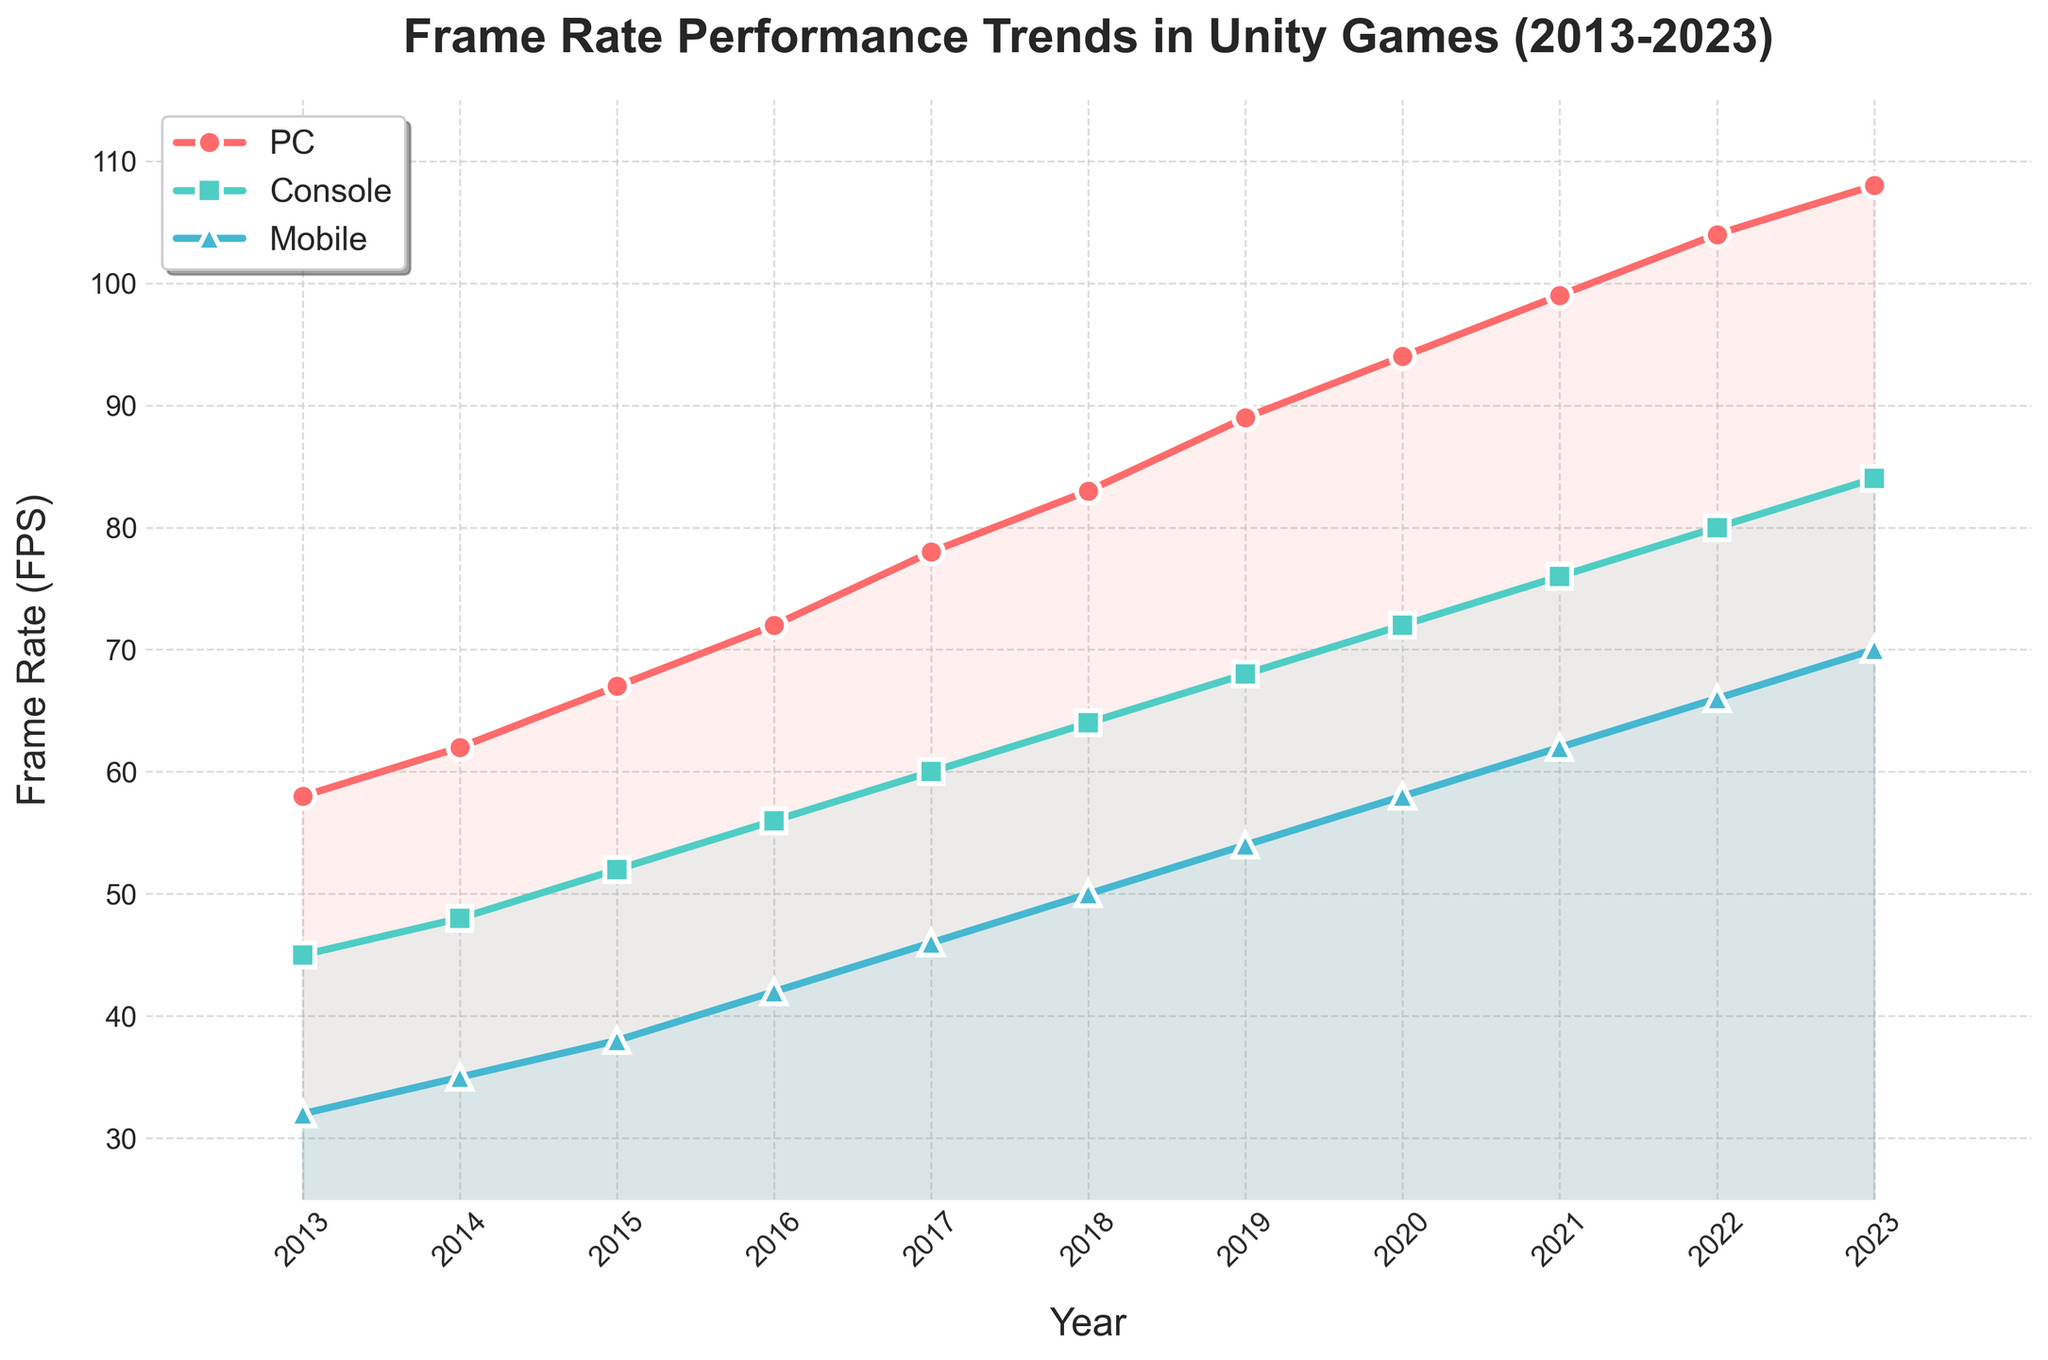What is the frame rate difference between PC and Console in 2013? The frame rate for PC in 2013 is 58 FPS, and for Console, it is 45 FPS. Subtract the frame rate of Console from PC: 58 - 45 = 13
Answer: 13 Which platform showed the greatest increase in frame rate from 2013 to 2023? The frame rates in 2013 and 2023 are: 
- PC: 58 FPS to 108 FPS
- Console: 45 FPS to 84 FPS
- Mobile: 32 FPS to 70 FPS
Compute the increase for each platform:
- PC: 108 - 58 = 50 FPS
- Console: 84 - 45 = 39 FPS
- Mobile: 70 - 32 = 38 FPS
The PC showed the greatest increase
Answer: PC In which year did Mobile reach a frame rate of 50 FPS? From the data, Mobile reaches 50 FPS in the year 2018
Answer: 2018 What is the average frame rate of Console from 2015 to 2020? The frame rates from 2015 to 2020 are 52, 56, 60, 64, 68, and 72 FPS. Sum these values and divide by the number of years: 
(52 + 56 + 60 + 64 + 68 + 72) / 6 = 372 / 6 = 62
Answer: 62 In the year 2020, how does the frame rate of Mobile compare to that of PC? In 2020, the frame rate for Mobile is 58 FPS, and for PC, it is 94 FPS. Since 58 is less than 94:
Mobile < PC
Answer: Mobile < PC Which platform saw the most consistent year-over-year increase in frame rate from 2013 to 2023? Calculate the difference between each year for all platforms:
- PC: (62-58), (67-62), ..., (108-104) which gives consistent increases of 4, 5, 5, 6, 5, 6, 5, 5, 5, 4 over the years.
- Console and Mobile have varying year-over-year differences. Therefore, PC has the most consistent increases
Answer: PC How does the slope of the line for PC from 2013 to 2023 visually compare to that of Mobile? Visually, the slope of the line for PC is steeper compared to Mobile, indicating PC's frame rate increased more rapidly than Mobile over the years.
Answer: Steeper What is the median frame rate of PC over the entire period? List out the frame rates for PC from 2013 to 2023:
58, 62, 67, 72, 78, 83, 89, 94, 99, 104, 108. The median is the middle value, so the 6th value: 83
Answer: 83 